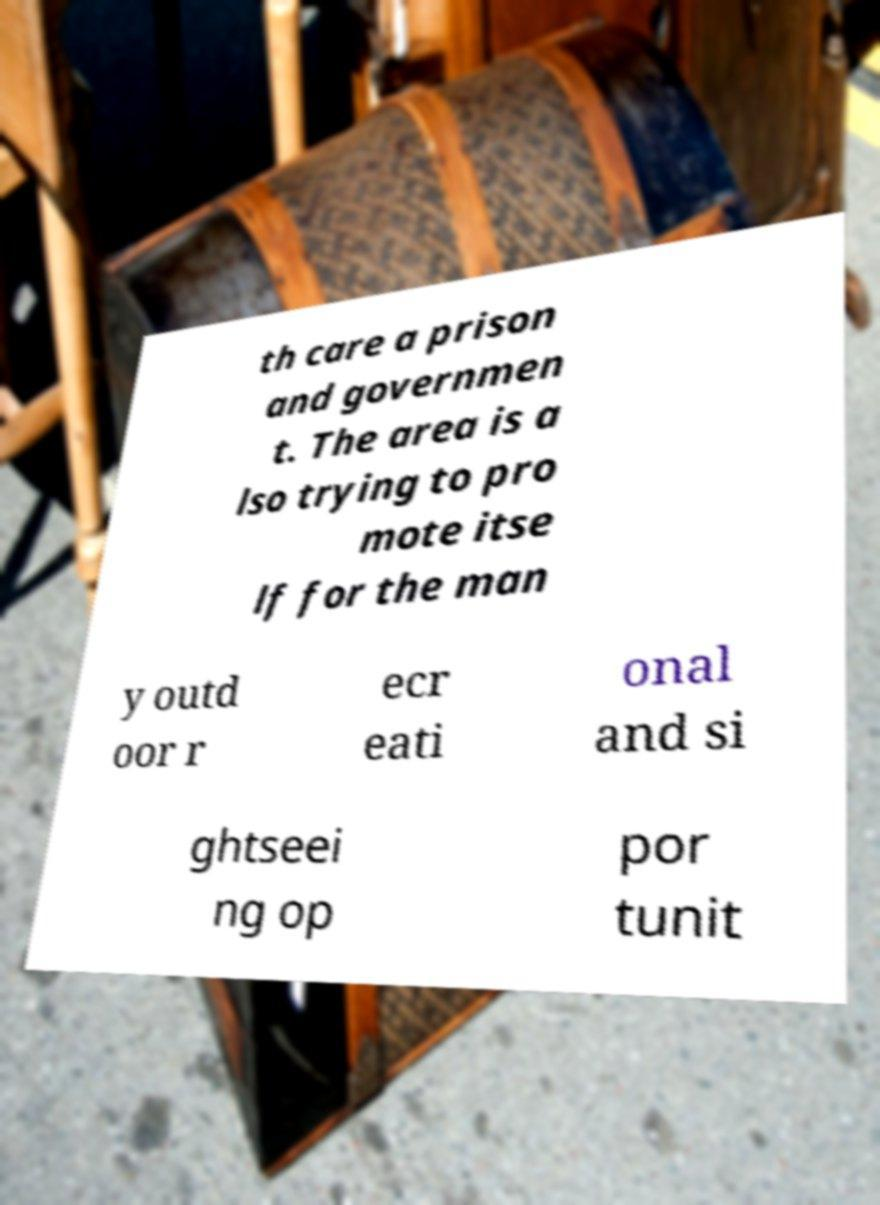There's text embedded in this image that I need extracted. Can you transcribe it verbatim? th care a prison and governmen t. The area is a lso trying to pro mote itse lf for the man y outd oor r ecr eati onal and si ghtseei ng op por tunit 